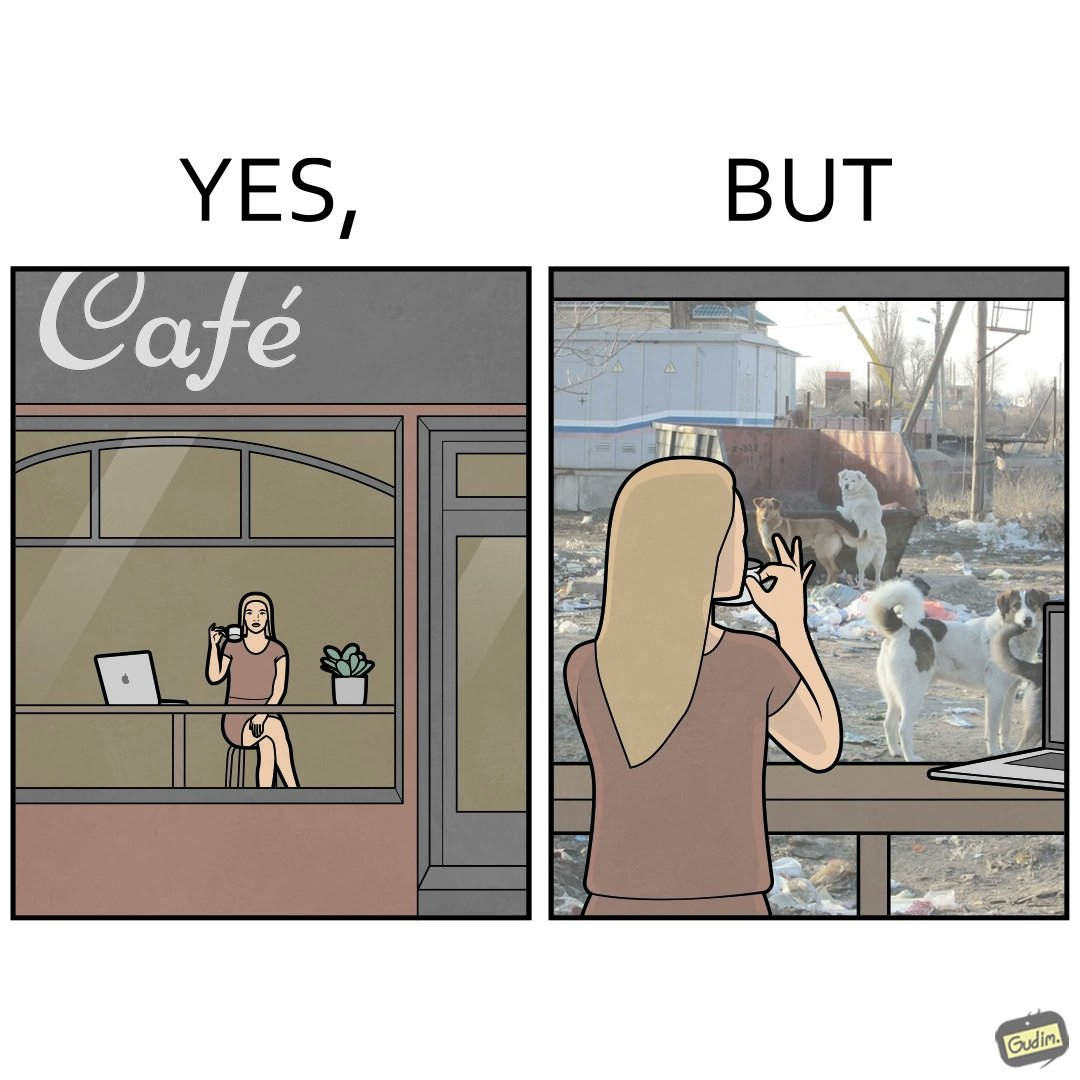What does this image depict? The people nowadays are not concerned about the surroundings, everyone is busy in their life, like in the image it is shown that even when the woman notices the issues faced by stray but even then she is not ready to raise her voice or do some action for the cause 